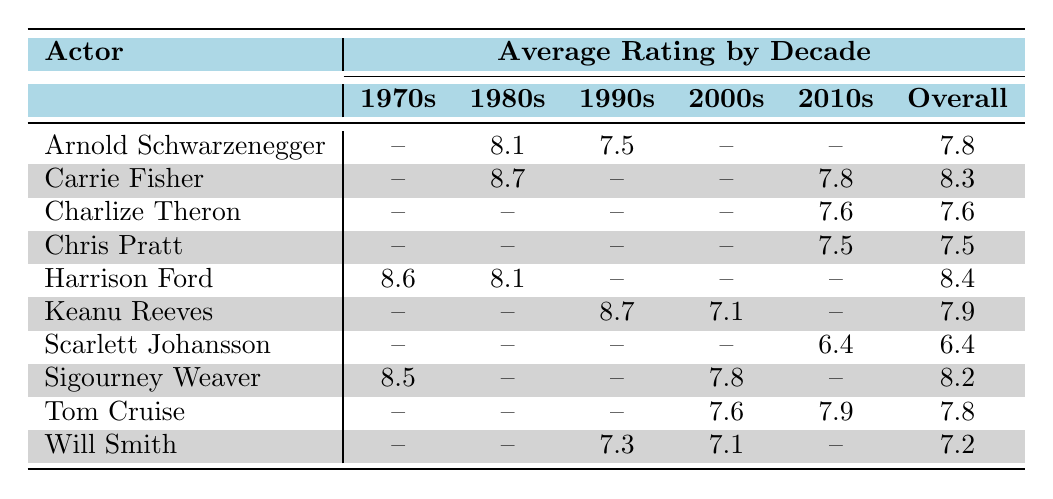What is the average rating for Arnold Schwarzenegger's science fiction films? According to the table, Arnold Schwarzenegger has two films listed: "The Terminator" rated 8.1 in the 1980s and "Total Recall" rated 7.5 in the 1990s. To calculate the average, we add the two ratings: (8.1 + 7.5) = 15.6, and divide by 2, giving us an average rating of 15.6 / 2 = 7.8.
Answer: 7.8 Which actor has the highest average rating in the 1980s? In the 1980s, we check the corresponding average ratings for each actor: Arnold Schwarzenegger is 8.1, Carrie Fisher is 8.7, and Harrison Ford is 8.1. The highest rating among these is Carrie Fisher's 8.7, making her the actor with the highest average rating in that decade.
Answer: Carrie Fisher Is Scarlett Johansson's overall average rating greater than 7? Scarlett Johansson has only one film listed, "Lucy" with a rating of 6.4. Since her overall average is solely based on this one film, it is not greater than 7, making the statement false.
Answer: No What is the difference between the average rating for films from the 1970s and those from the 2010s? We calculate the average for the 1970s: Harrison Ford 8.6 and Sigourney Weaver 8.5 gives 8.55. For the 2010s, we take Carrie Fisher 7.8, Charlize Theron 7.6, Tom Cruise 7.9, Chris Pratt 7.5, and Scarlett Johansson 6.3, averaging to 7.62. The difference is 8.55 - 7.62 = 0.93.
Answer: 0.93 Is it true that all actors listed have at least one film in the 2000s? Looking at the table, Keanu Reeves, Will Smith, Tom Cruise, and Sigourney Weaver all have films in the 2000s, but Arnold Schwarzenegger and Carrie Fisher do not, as they have no entries for that decade. Therefore, the statement is false.
Answer: No 